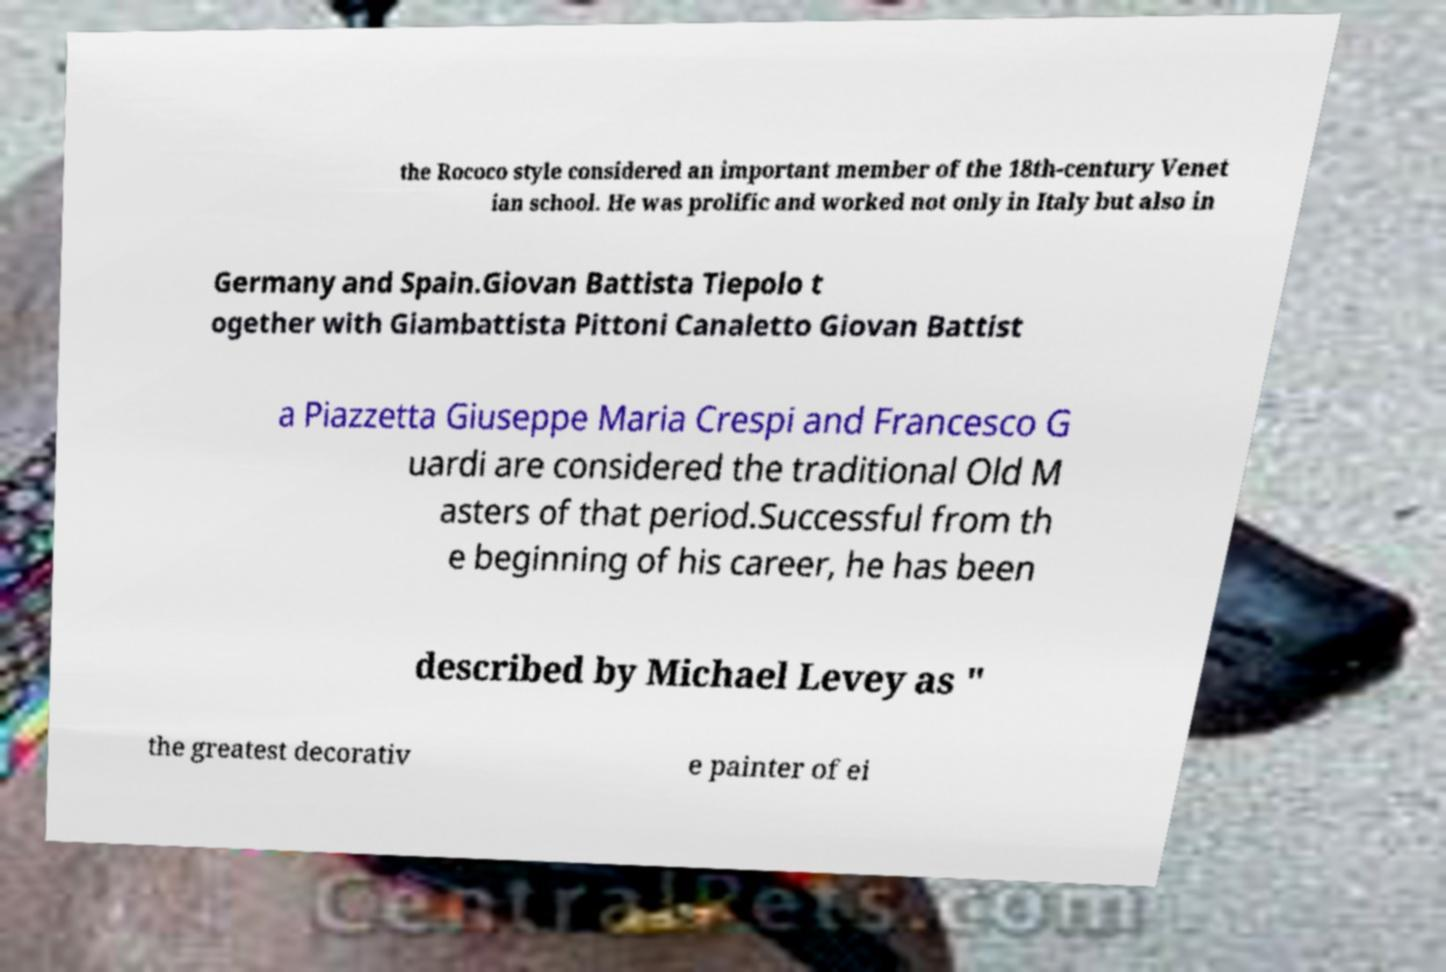There's text embedded in this image that I need extracted. Can you transcribe it verbatim? the Rococo style considered an important member of the 18th-century Venet ian school. He was prolific and worked not only in Italy but also in Germany and Spain.Giovan Battista Tiepolo t ogether with Giambattista Pittoni Canaletto Giovan Battist a Piazzetta Giuseppe Maria Crespi and Francesco G uardi are considered the traditional Old M asters of that period.Successful from th e beginning of his career, he has been described by Michael Levey as " the greatest decorativ e painter of ei 